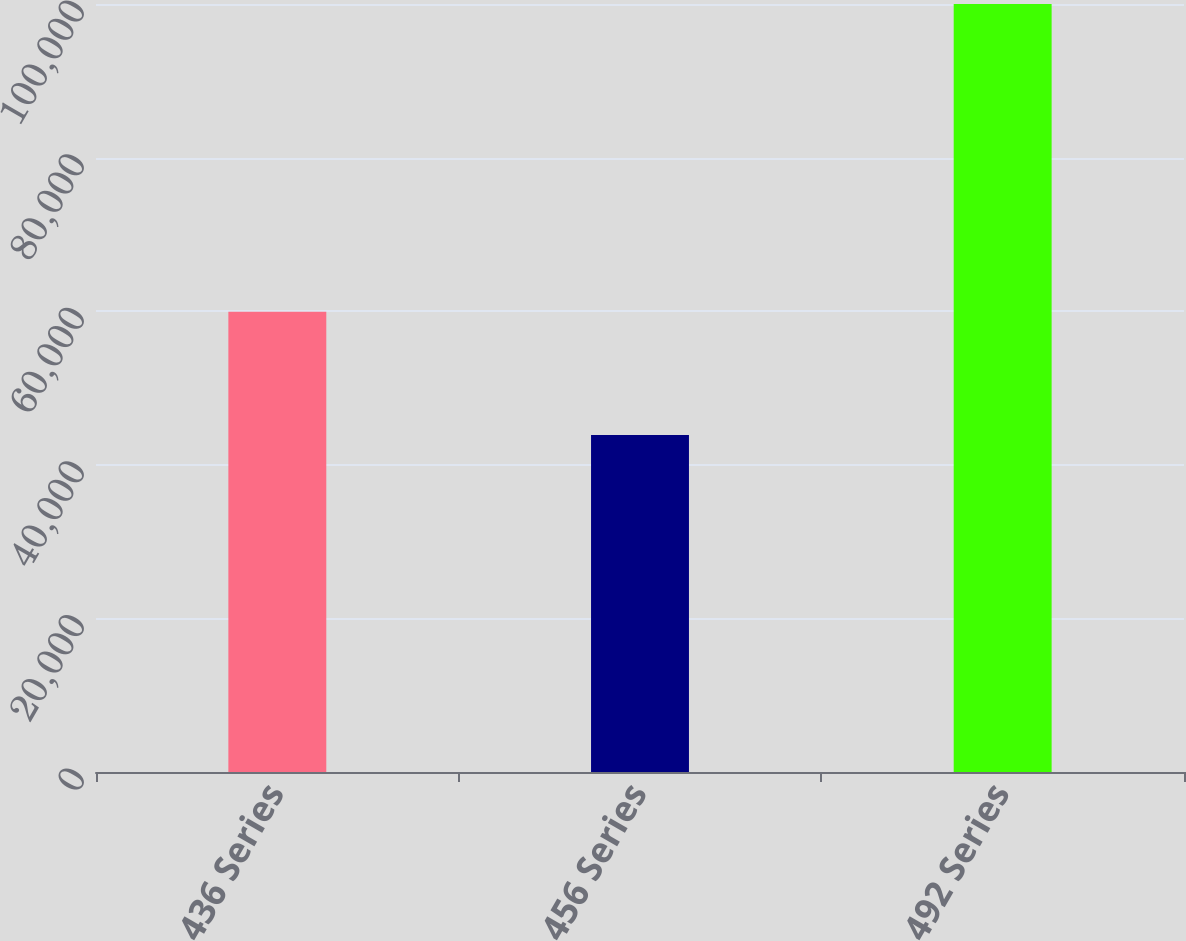<chart> <loc_0><loc_0><loc_500><loc_500><bar_chart><fcel>436 Series<fcel>456 Series<fcel>492 Series<nl><fcel>59920<fcel>43887<fcel>100000<nl></chart> 